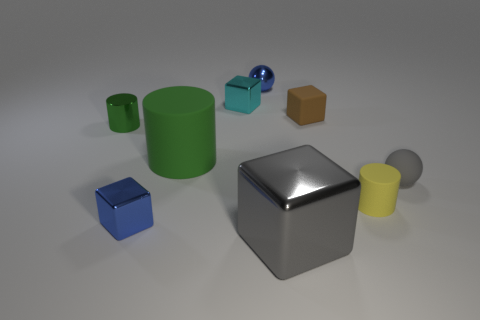Subtract all green blocks. Subtract all yellow balls. How many blocks are left? 4 Add 1 brown metallic cubes. How many objects exist? 10 Subtract all blocks. How many objects are left? 5 Add 2 cyan metallic things. How many cyan metallic things are left? 3 Add 3 gray metal things. How many gray metal things exist? 4 Subtract 0 yellow blocks. How many objects are left? 9 Subtract all tiny brown cubes. Subtract all small yellow shiny balls. How many objects are left? 8 